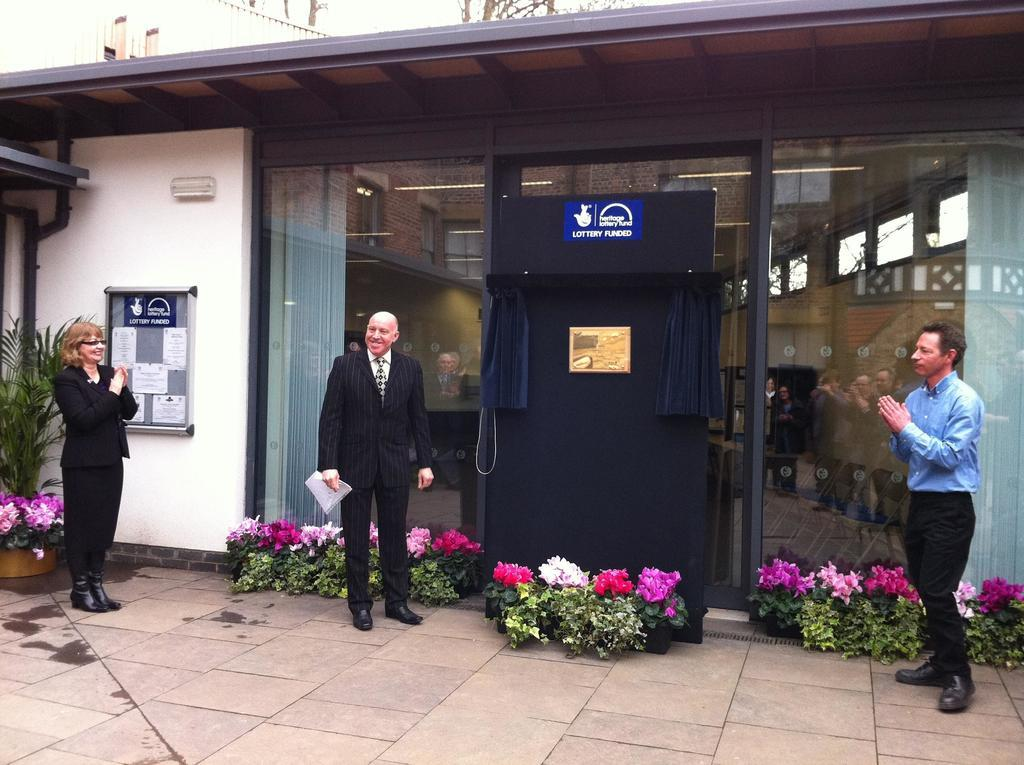Provide a one-sentence caption for the provided image. Three people stand outside a building for the Heritage Lottery Fund. 